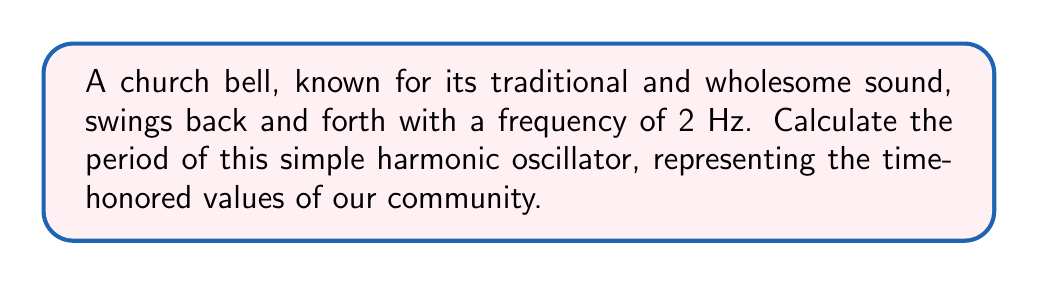What is the answer to this math problem? To determine the period of a simple harmonic oscillator, we need to understand the relationship between frequency and period:

1) The period (T) is defined as the time taken for one complete oscillation.

2) Frequency (f) is the number of oscillations per unit time.

3) The relationship between period and frequency is given by:

   $$T = \frac{1}{f}$$

4) In this case, we are given the frequency:
   
   $f = 2$ Hz

5) Substituting this into our equation:

   $$T = \frac{1}{2} \text{ seconds}$$

6) Therefore, the period of the church bell's oscillation is 0.5 seconds.

This calculation shows that the bell completes one full swing every half second, maintaining its steady, reliable rhythm that has been a staple of our community for generations.
Answer: $T = 0.5$ s 